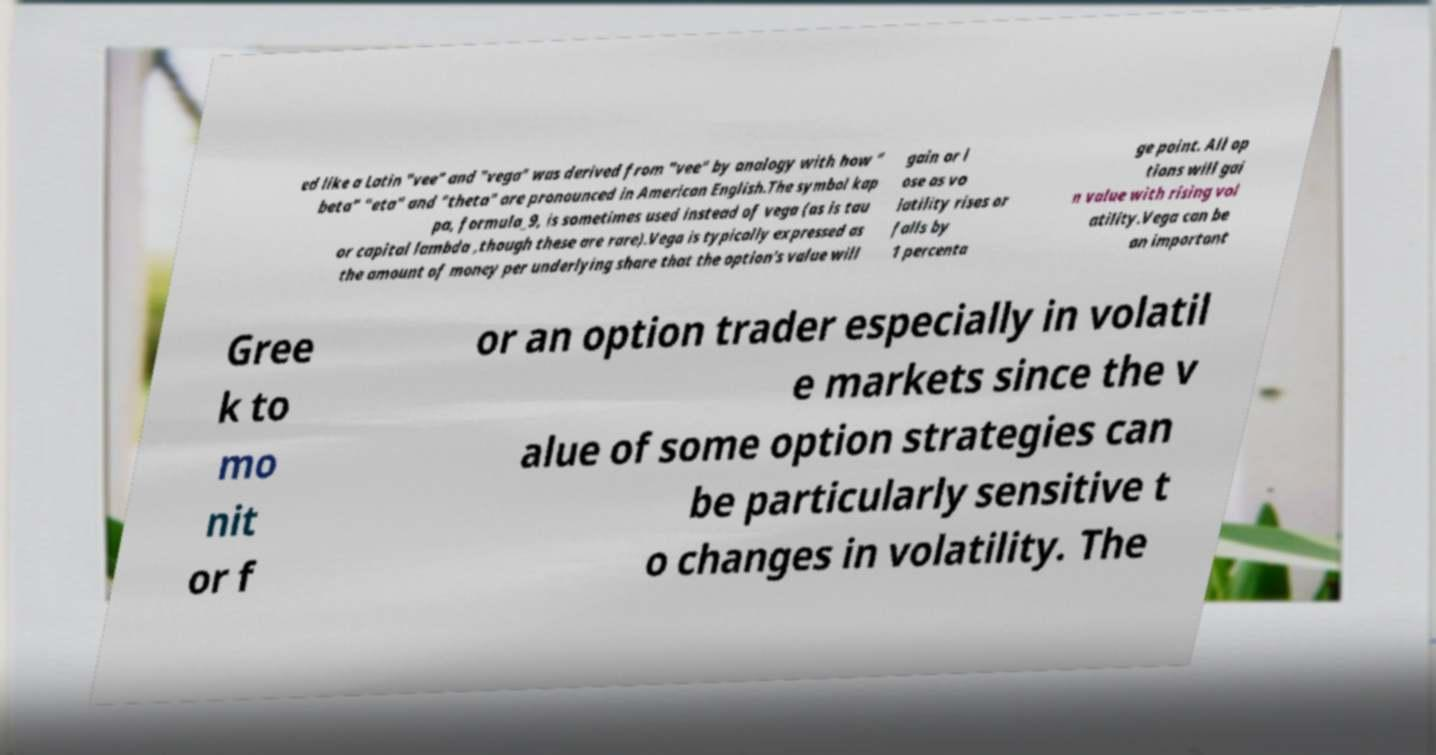Could you assist in decoding the text presented in this image and type it out clearly? ed like a Latin "vee" and "vega" was derived from "vee" by analogy with how " beta" "eta" and "theta" are pronounced in American English.The symbol kap pa, formula_9, is sometimes used instead of vega (as is tau or capital lambda ,though these are rare).Vega is typically expressed as the amount of money per underlying share that the option's value will gain or l ose as vo latility rises or falls by 1 percenta ge point. All op tions will gai n value with rising vol atility.Vega can be an important Gree k to mo nit or f or an option trader especially in volatil e markets since the v alue of some option strategies can be particularly sensitive t o changes in volatility. The 